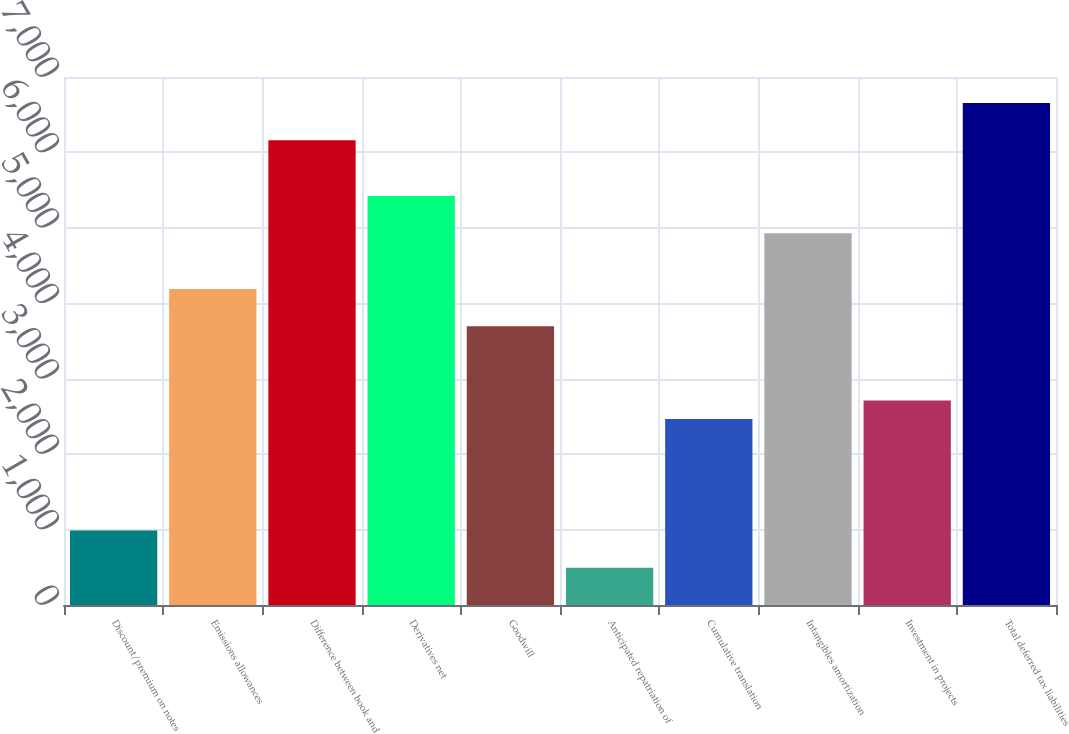Convert chart to OTSL. <chart><loc_0><loc_0><loc_500><loc_500><bar_chart><fcel>Discount/premium on notes<fcel>Emissions allowances<fcel>Difference between book and<fcel>Derivatives net<fcel>Goodwill<fcel>Anticipated repatriation of<fcel>Cumulative translation<fcel>Intangibles amortization<fcel>Investment in projects<fcel>Total deferred tax liabilities<nl><fcel>986.6<fcel>4189.8<fcel>6161<fcel>5421.8<fcel>3697<fcel>493.8<fcel>2465<fcel>4929<fcel>2711.4<fcel>6653.8<nl></chart> 